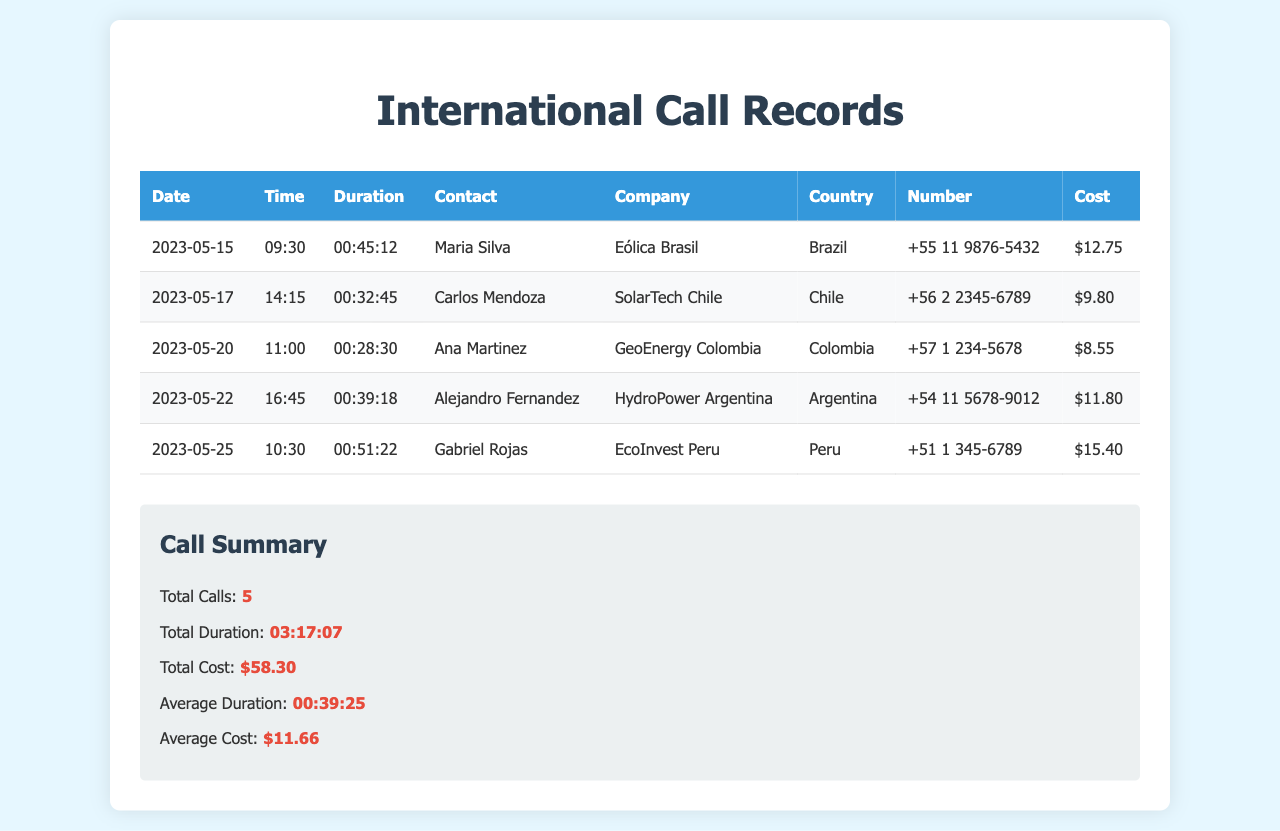What is the total number of calls? The total number of calls is listed in the summary section of the document.
Answer: 5 Who did you call in Brazil? The contact information for Brazil is provided in the table.
Answer: Maria Silva What is the cost of the call to Peru? The cost for the Peru call is stated in the table under the 'Cost' column.
Answer: $15.40 Which company is associated with the call to Argentina? The table provides the company name linked to the Argentina call.
Answer: HydroPower Argentina What is the average duration of the calls? The average duration is summarized at the end of the document.
Answer: 00:39:25 How long was the longest call? The duration of each call is presented, and the longest can be identified from the table.
Answer: 00:51:22 How many countries were called? The number of distinct countries is found by counting the entries in the 'Country' column.
Answer: 5 What is the total cost of all calls? The total cost is provided in the summary section of the document.
Answer: $58.30 